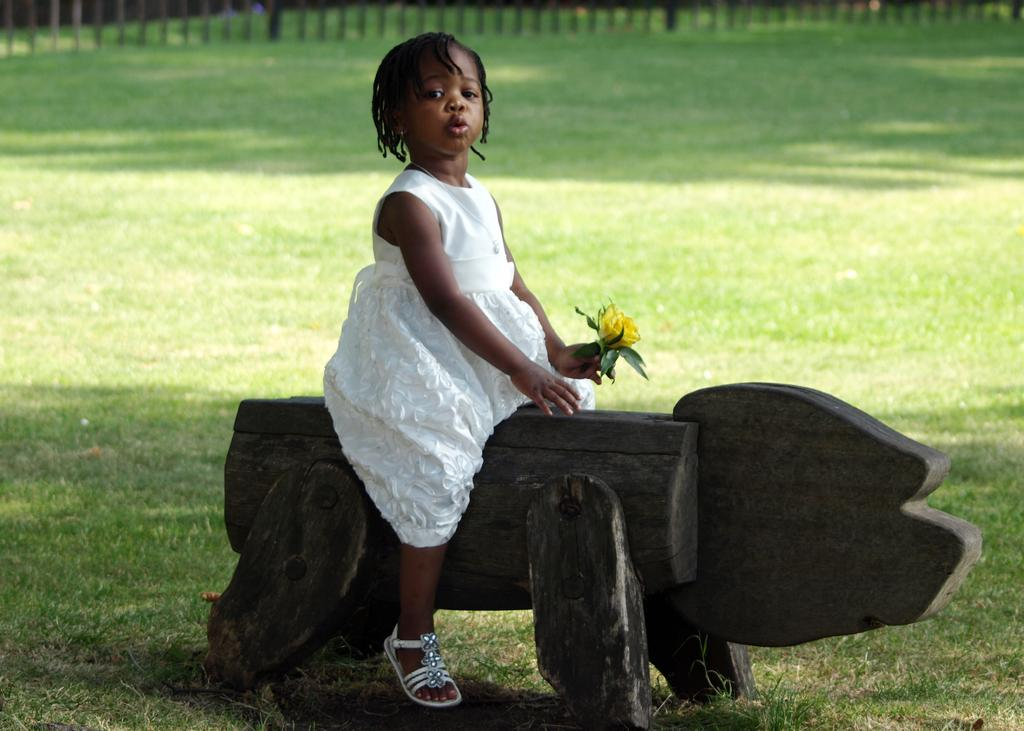Who is in the image? There is a girl in the image. What is the girl holding? The girl is holding a flower. What is the girl sitting on? The girl is sitting on a wooden object. What type of vegetation is present in the image? There is grass in the image. What can be seen at the top of the image? There is a fence visible at the top of the image. What type of trucks can be seen in the background of the image? There are no trucks present in the image; it features a girl holding a flower and sitting on a wooden object, with grass and a fence visible. 